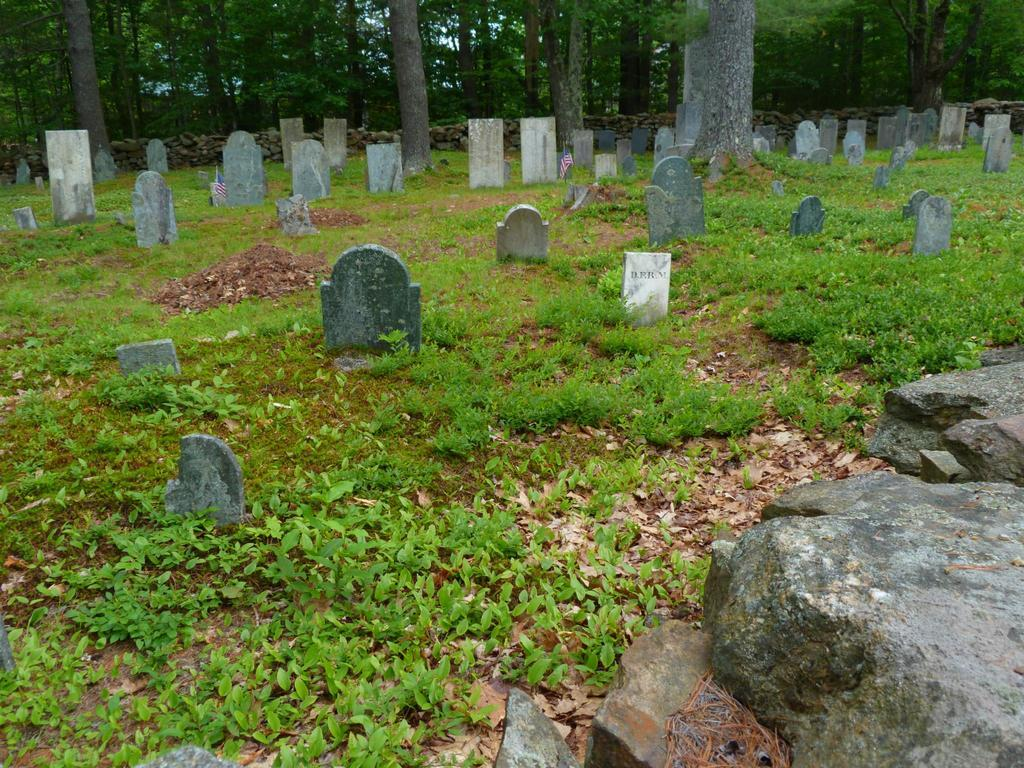What type of living organisms can be seen in the image? Plants and trees are visible in the image. What type of ground cover is present in the image? There is grass in the image. What type of material are the plates made of in the image? The plates in the image are made of stone. What can be seen in the background of the image? There are trees in the background of the image. How many bikes are parked next to the plants in the image? There are no bikes present in the image. What emotion is the person in the image feeling, and how can you tell? There is no person present in the image, so it is not possible to determine their emotions. 